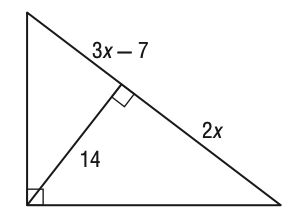Question: What is the value of x in the figure below?
Choices:
A. 5
B. 7
C. 8
D. 10
Answer with the letter. Answer: B 